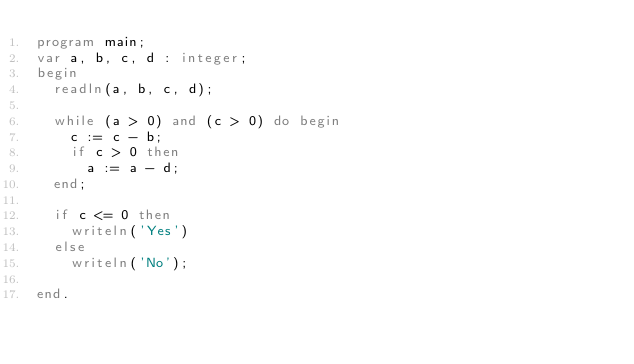<code> <loc_0><loc_0><loc_500><loc_500><_Pascal_>program main;
var a, b, c, d : integer;
begin
  readln(a, b, c, d);

  while (a > 0) and (c > 0) do begin
    c := c - b;
    if c > 0 then
      a := a - d;
  end;

  if c <= 0 then
    writeln('Yes')
  else
    writeln('No');

end.</code> 